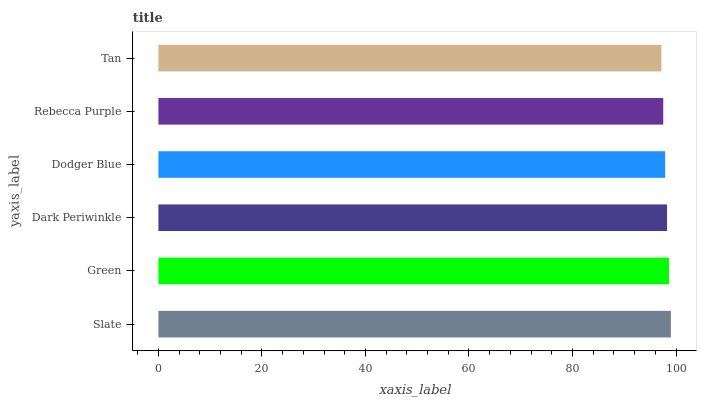Is Tan the minimum?
Answer yes or no. Yes. Is Slate the maximum?
Answer yes or no. Yes. Is Green the minimum?
Answer yes or no. No. Is Green the maximum?
Answer yes or no. No. Is Slate greater than Green?
Answer yes or no. Yes. Is Green less than Slate?
Answer yes or no. Yes. Is Green greater than Slate?
Answer yes or no. No. Is Slate less than Green?
Answer yes or no. No. Is Dark Periwinkle the high median?
Answer yes or no. Yes. Is Dodger Blue the low median?
Answer yes or no. Yes. Is Tan the high median?
Answer yes or no. No. Is Rebecca Purple the low median?
Answer yes or no. No. 